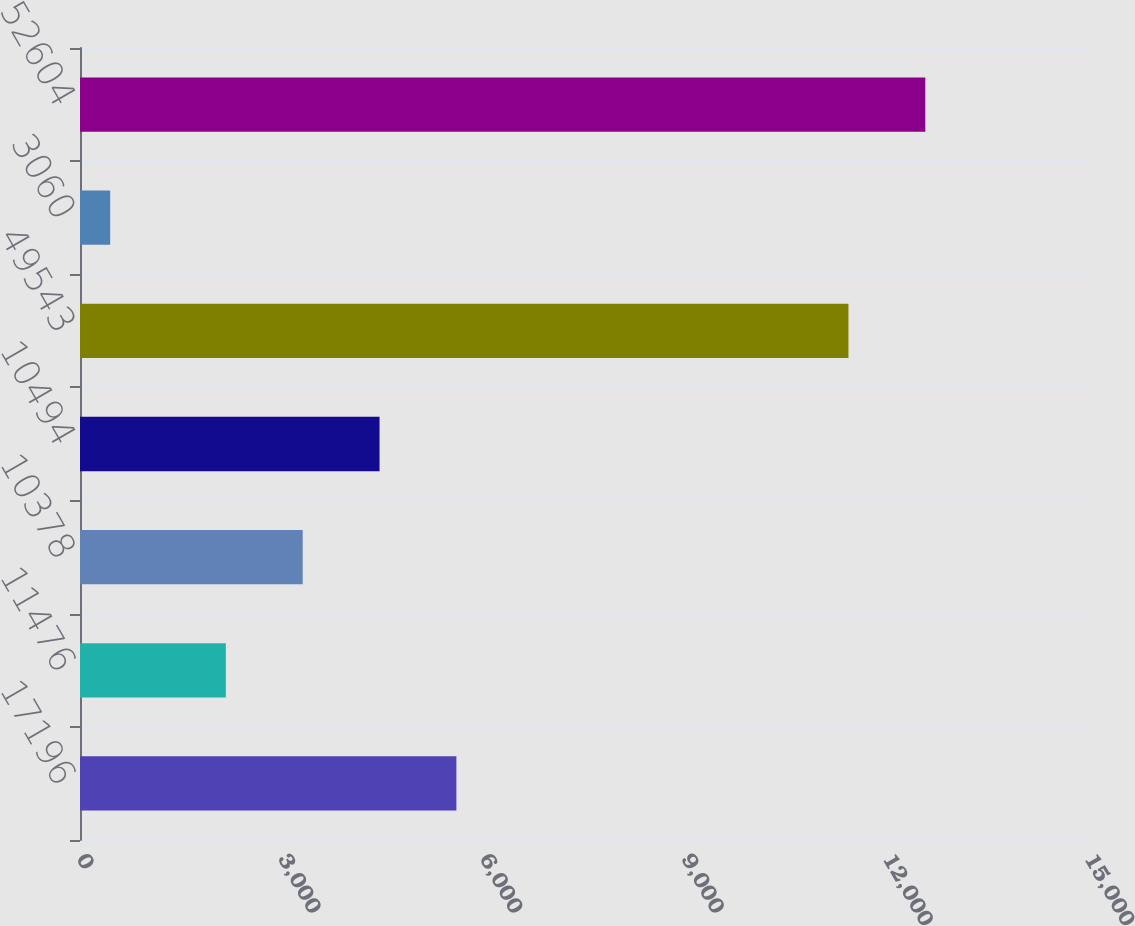<chart> <loc_0><loc_0><loc_500><loc_500><bar_chart><fcel>17196<fcel>11476<fcel>10378<fcel>10494<fcel>49543<fcel>3060<fcel>52604<nl><fcel>5601.09<fcel>2170.5<fcel>3314.03<fcel>4457.56<fcel>11435.3<fcel>449<fcel>12578.8<nl></chart> 